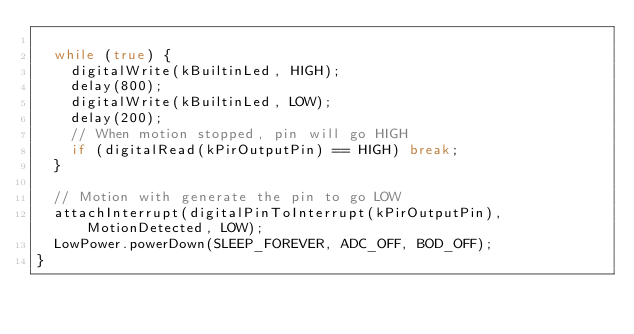Convert code to text. <code><loc_0><loc_0><loc_500><loc_500><_C++_>
  while (true) {
    digitalWrite(kBuiltinLed, HIGH);
    delay(800);
    digitalWrite(kBuiltinLed, LOW);
    delay(200);
    // When motion stopped, pin will go HIGH
    if (digitalRead(kPirOutputPin) == HIGH) break;
  }

  // Motion with generate the pin to go LOW
  attachInterrupt(digitalPinToInterrupt(kPirOutputPin), MotionDetected, LOW);
  LowPower.powerDown(SLEEP_FOREVER, ADC_OFF, BOD_OFF);
}
</code> 